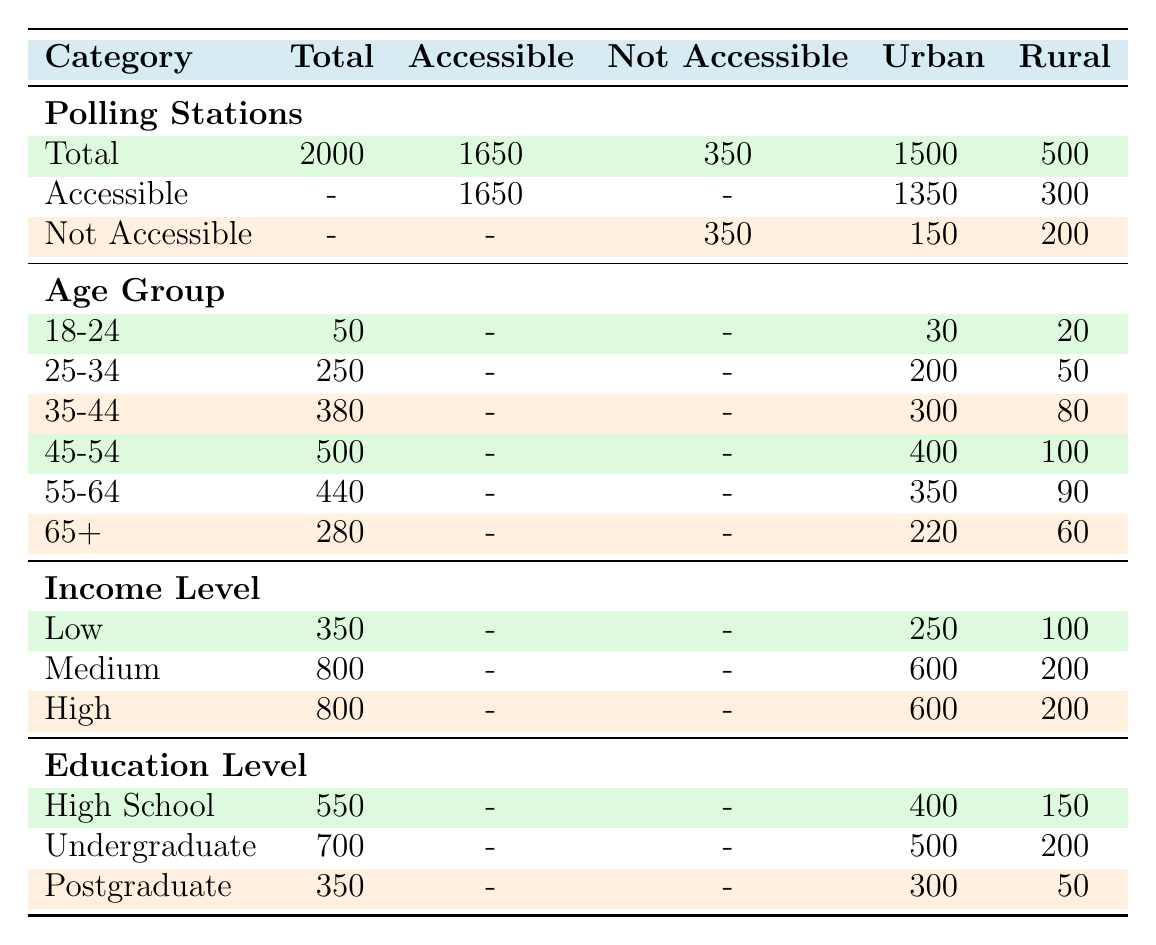What is the total number of polling stations in urban areas? The table shows that the total number of polling stations in the Urban category is directly listed under the column "Total" for Urban, which is 1500.
Answer: 1500 How many polling stations in rural areas are accessible? According to the table, the number of accessible polling stations in the Rural category is directly listed under the "Accessible" column, which is 300.
Answer: 300 Is the number of accessible polling stations greater in urban or rural areas? From the table, there are 1350 accessible polling stations in Urban areas and 300 in Rural areas. Since 1350 is greater than 300, the answer is Urban areas have more accessible polling stations.
Answer: Yes What is the total number of polling stations that are not accessible? The table indicates that the total number of not accessible polling stations is found under the "Not Accessible" row, which adds up to 350 (150 in Urban and 200 in Rural).
Answer: 350 What percentage of polling stations in urban areas are accessible? To find the percentage of accessible polling stations in Urban areas, divide the number of accessible polling stations (1350) by the total polling stations (1500) and multiply by 100. Calculation: (1350 / 1500) * 100 = 90%.
Answer: 90% Which age group has the highest number of accessible polling stations in urban areas? By looking at the Age Group section in the Urban category, we see the accessible counts for the age groups: 30 (18-24), 200 (25-34), 300 (35-44), 400 (45-54), 350 (55-64), and 220 (65+). The maximum is 400 from the 45-54 age group.
Answer: 45-54 What is the difference in the number of accessible polling stations between the highest income level in urban and rural areas? In the Urban category, there are 600 accessible polling stations for the High-income level, and in Rural, also 200. The difference is calculated as 600 - 200 = 400.
Answer: 400 Is the total number of not accessible polling stations greater than the total number of accessible polling stations in rural areas? In the Rural category, there are 300 accessible polling stations and 200 not accessible. Comparing these, 200 is not greater than 300, thus the statement is false.
Answer: No What is the combined total of accessible polling stations for all age groups in urban areas? By summing the accessible counts for each age group in Urban, we find: 30 + 200 + 300 + 400 + 350 + 220 = 1500.
Answer: 1500 